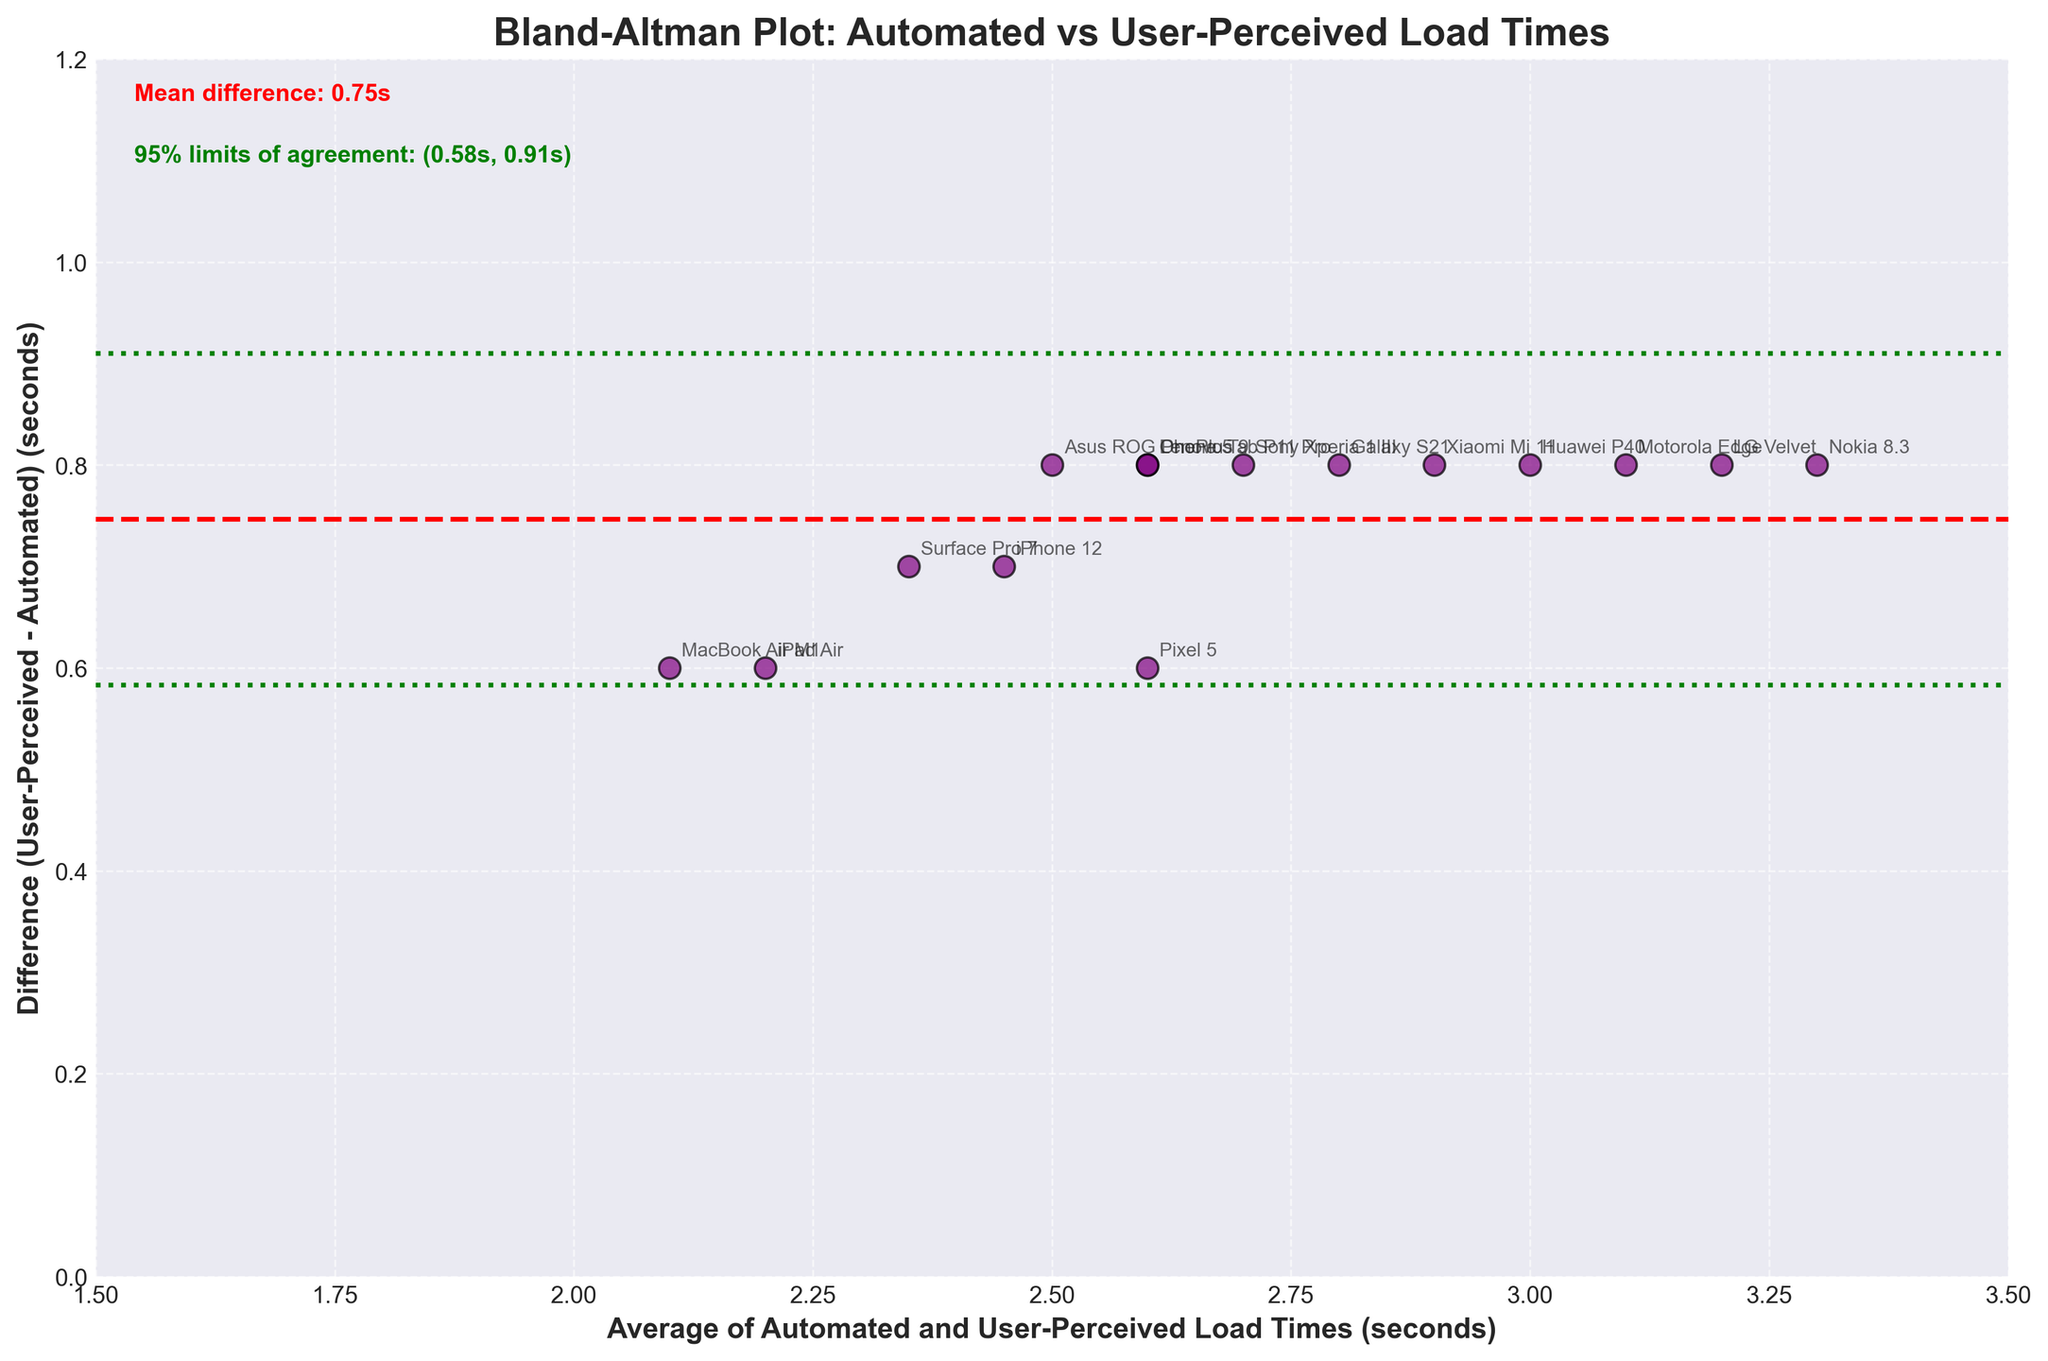What is the title of the figure? The title of the figure is written at the top of the plot. It is "Bland-Altman Plot: Automated vs User-Perceived Load Times".
Answer: Bland-Altman Plot: Automated vs User-Perceived Load Times What does the x-axis represent? The x-axis label indicates that it represents "Average of Automated and User-Perceived Load Times (seconds)".
Answer: Average of Automated and User-Perceived Load Times (seconds) What is the mean difference between user-perceived and automated load times? The mean difference is annotated on the plot near the top left. It shows a mean difference of 0.77s.
Answer: 0.77s What are the 95% limits of agreement as shown in the plot? These limits are annotated on the plot near the top left. The 95% limits of agreement are between 0.12s and 1.41s.
Answer: 0.12s and 1.41s Which device has the highest load time difference (user-perceived - automated)? By examining the plot, the device with the most significant vertical position indicates the highest difference. The Nokia 8.3 has the highest difference.
Answer: Nokia 8.3 What is the average load time (automated and user-perceived) for the iPhone 12? Find the coordinates of the iPhone 12 on the plot to determine the x-axis value. The x-axis (average load time) for the iPhone 12 is about 2.45s.
Answer: 2.45s Which device has an average load time closest to 2.5 seconds? By looking at the x-axis, the device closest to 2.5 seconds average load time is Pixel 5.
Answer: Pixel 5 How does the load time difference for Galaxy S21 compare to the mean difference? Compare the difference for Galaxy S21 to the annotated mean difference line. Galaxy S21 has a difference of 0.8s, which is slightly above the mean difference of 0.77s.
Answer: Slightly above What device has a difference closest to the lower limit of agreement? Look at the plot for data points near the lower green line. The Surface Pro 7 has a difference close to the lower limit of 0.12s.
Answer: Surface Pro 7 Do most devices show a consistent trend in the difference between user-perceived and automated load times? Most data points display differences within a narrow range around the mean difference line, indicating a consistent measurement trend.
Answer: Yes 